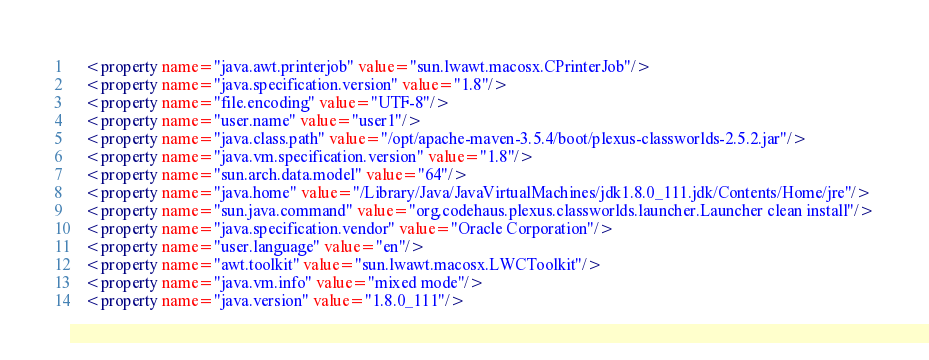<code> <loc_0><loc_0><loc_500><loc_500><_XML_>    <property name="java.awt.printerjob" value="sun.lwawt.macosx.CPrinterJob"/>
    <property name="java.specification.version" value="1.8"/>
    <property name="file.encoding" value="UTF-8"/>
    <property name="user.name" value="user1"/>
    <property name="java.class.path" value="/opt/apache-maven-3.5.4/boot/plexus-classworlds-2.5.2.jar"/>
    <property name="java.vm.specification.version" value="1.8"/>
    <property name="sun.arch.data.model" value="64"/>
    <property name="java.home" value="/Library/Java/JavaVirtualMachines/jdk1.8.0_111.jdk/Contents/Home/jre"/>
    <property name="sun.java.command" value="org.codehaus.plexus.classworlds.launcher.Launcher clean install"/>
    <property name="java.specification.vendor" value="Oracle Corporation"/>
    <property name="user.language" value="en"/>
    <property name="awt.toolkit" value="sun.lwawt.macosx.LWCToolkit"/>
    <property name="java.vm.info" value="mixed mode"/>
    <property name="java.version" value="1.8.0_111"/></code> 